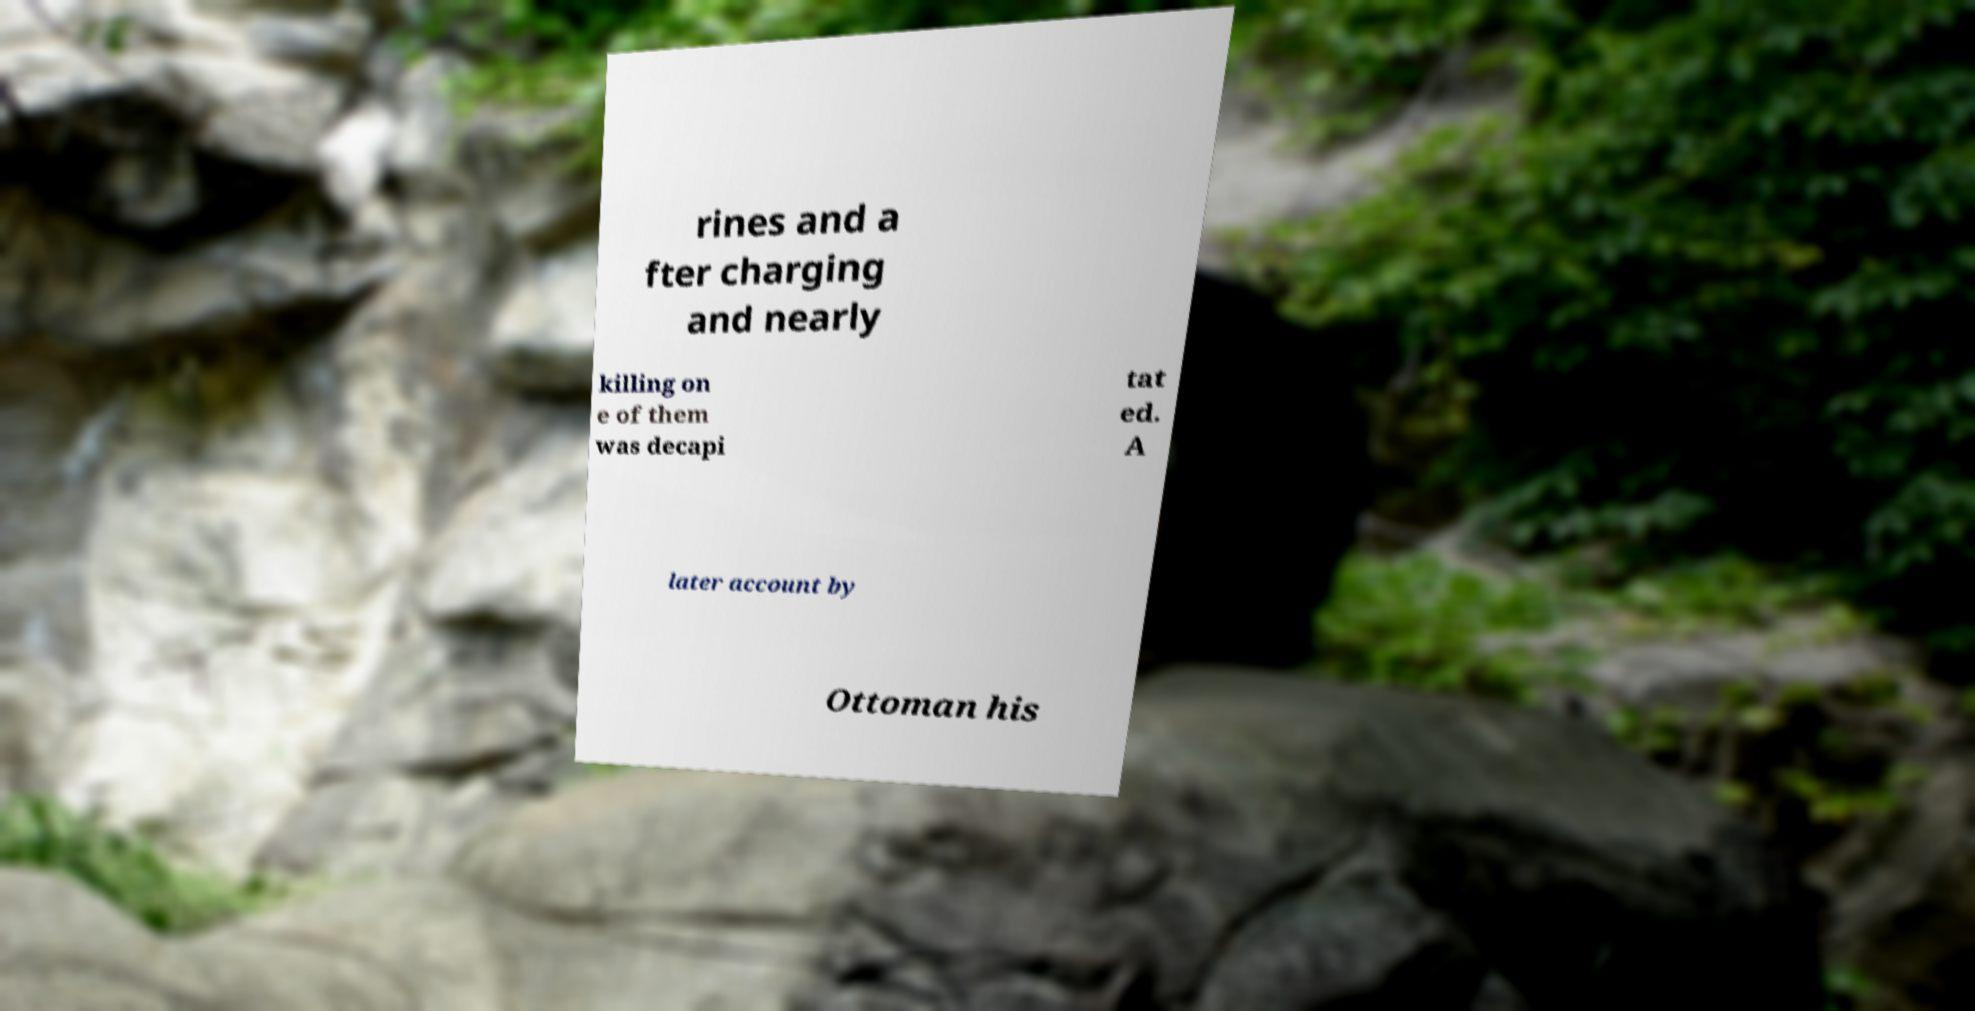Can you accurately transcribe the text from the provided image for me? rines and a fter charging and nearly killing on e of them was decapi tat ed. A later account by Ottoman his 